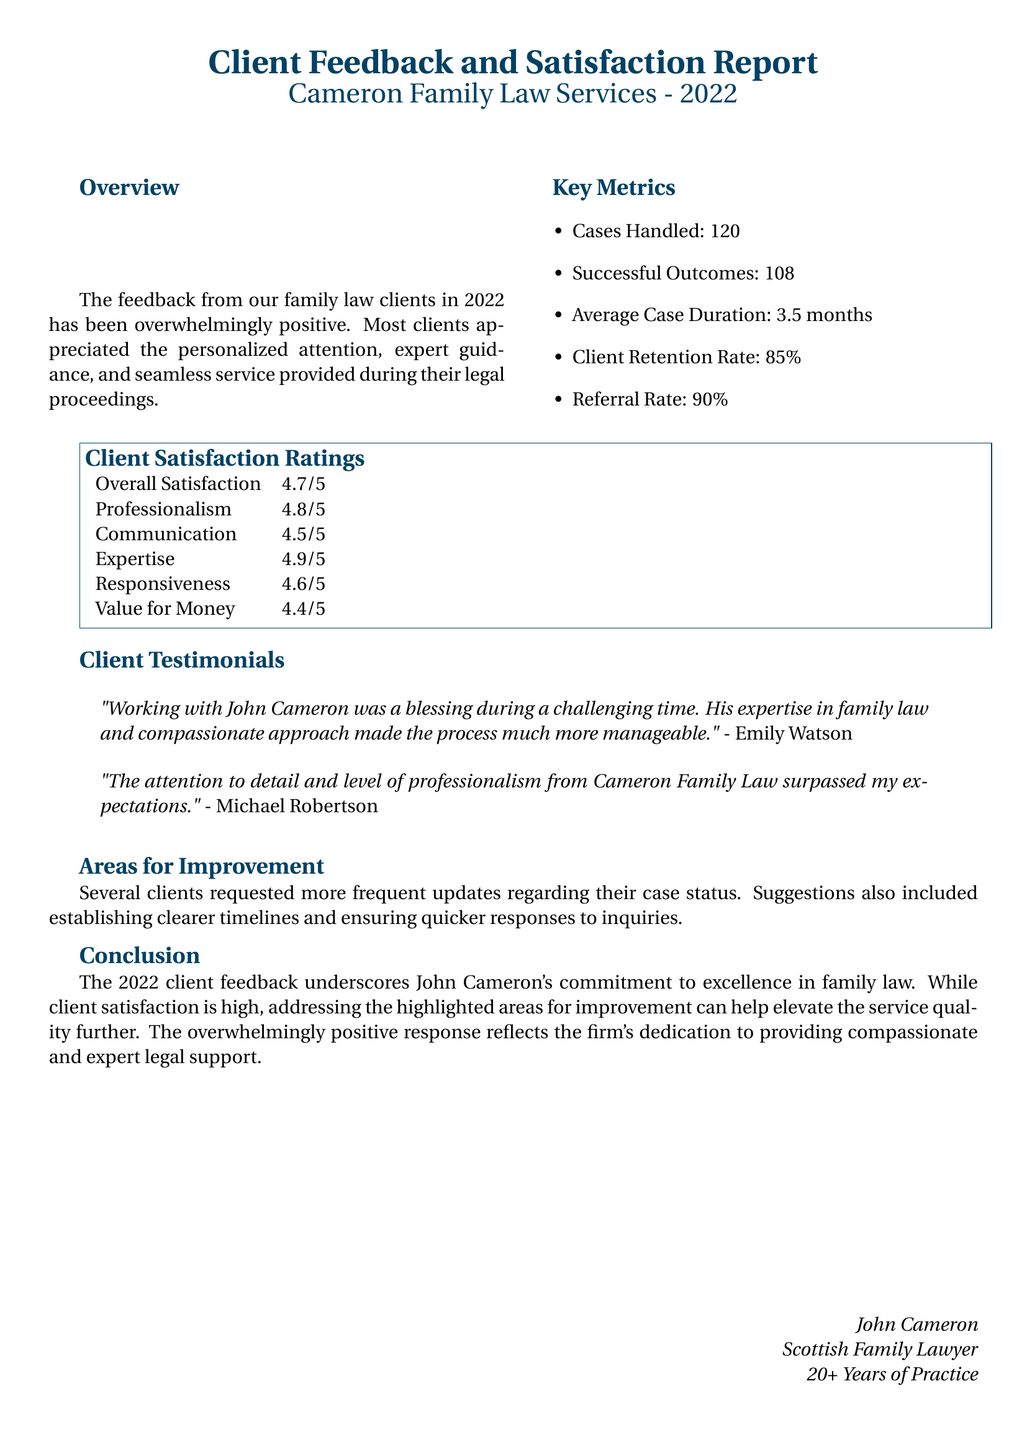What was the average case duration? The average case duration is presented as the time taken to resolve cases, which is calculated from the handled cases.
Answer: 3.5 months How many cases were handled? The document specifies the total count of cases managed during the year 2022.
Answer: 120 What was the overall satisfaction rating? The overall satisfaction reflects how satisfied clients were with the services, expressed as a numerical rating.
Answer: 4.7/5 Who provided a testimonial describing the experience as a "blessing"? This kind of inquiry seeks to identify the individual who expressed gratitude in their feedback.
Answer: Emily Watson What percentage represents the client retention rate? The percentage given reflects the firm's effectiveness in retaining clients, as noted in the metrics section.
Answer: 85% Which area received the highest rating in client satisfaction? This question aims to find the specific service aspect that clients rated most positively, showing the firm's strengths.
Answer: Expertise What common area for improvement did clients mention? This question focuses on the feedback section that identifies weaknesses in the service delivery.
Answer: More frequent updates What was the referral rate? The referral rate indicates how many clients were likely to recommend the firm's services based on their experience.
Answer: 90% 